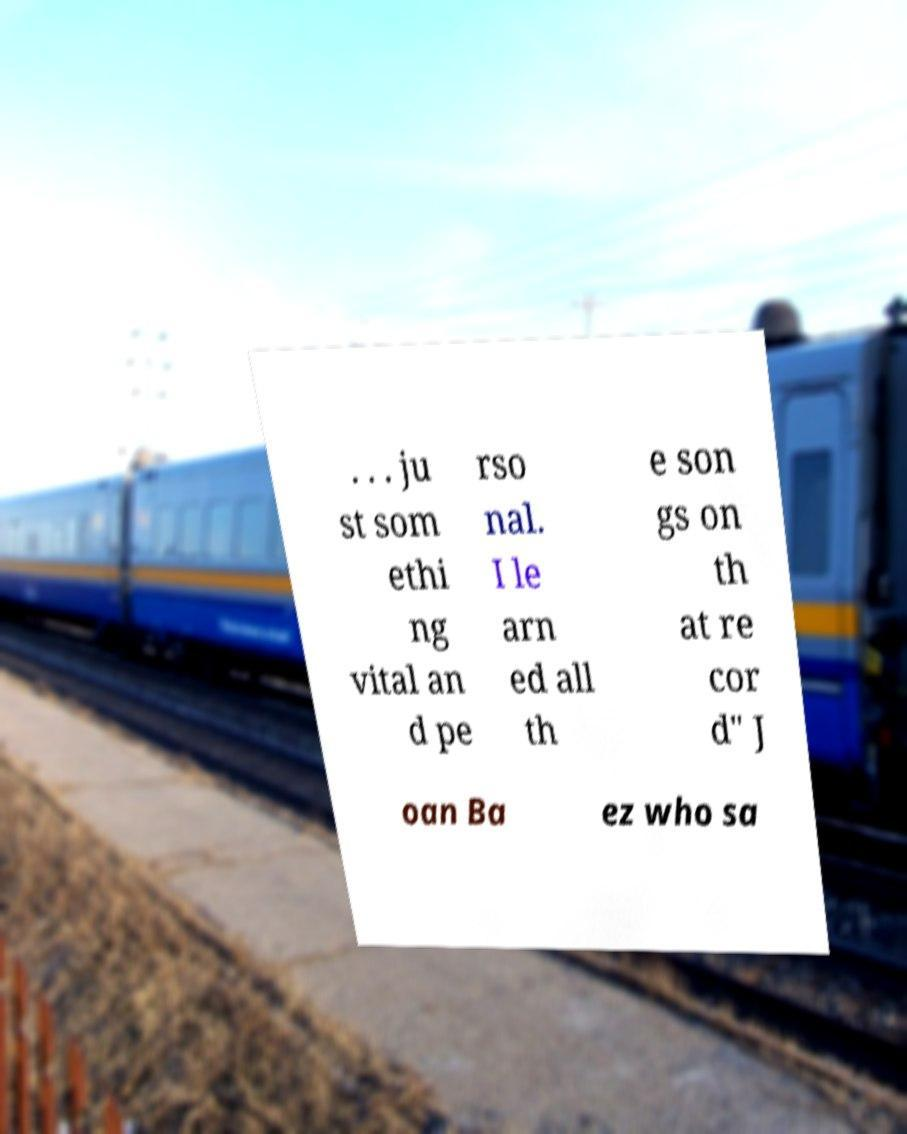Can you read and provide the text displayed in the image?This photo seems to have some interesting text. Can you extract and type it out for me? . . . ju st som ethi ng vital an d pe rso nal. I le arn ed all th e son gs on th at re cor d" J oan Ba ez who sa 